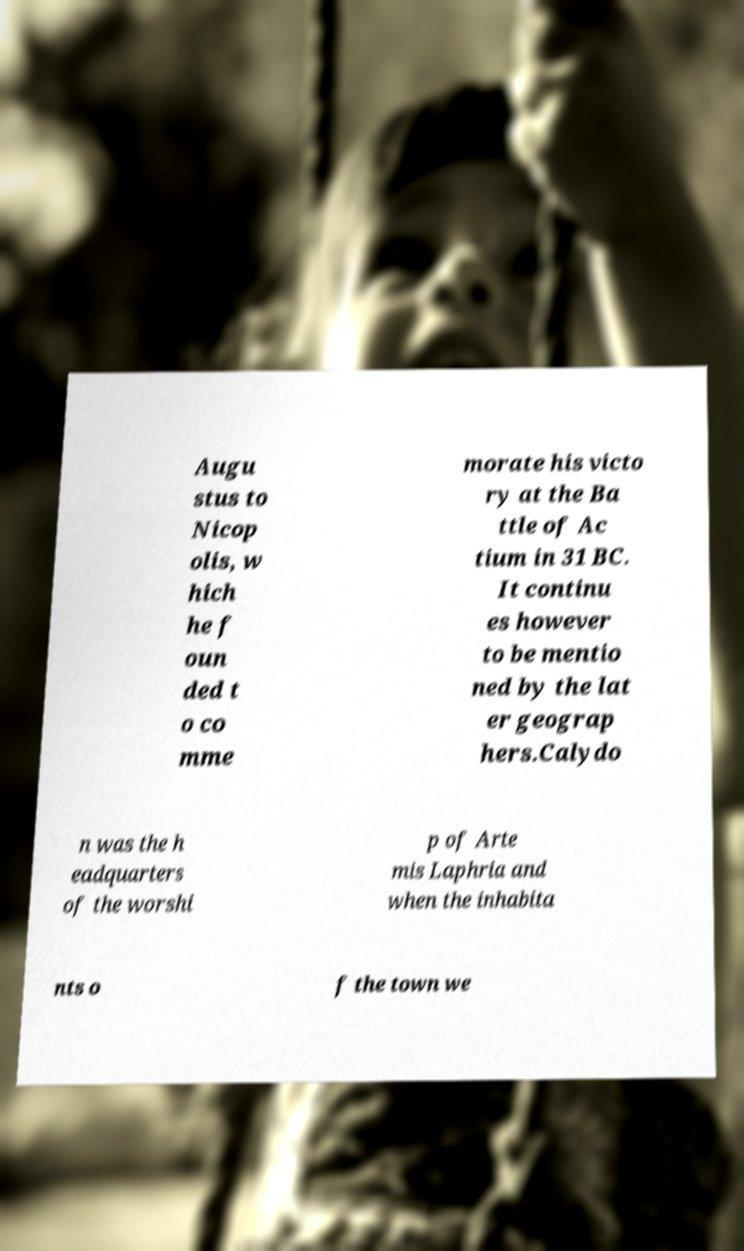I need the written content from this picture converted into text. Can you do that? Augu stus to Nicop olis, w hich he f oun ded t o co mme morate his victo ry at the Ba ttle of Ac tium in 31 BC. It continu es however to be mentio ned by the lat er geograp hers.Calydo n was the h eadquarters of the worshi p of Arte mis Laphria and when the inhabita nts o f the town we 